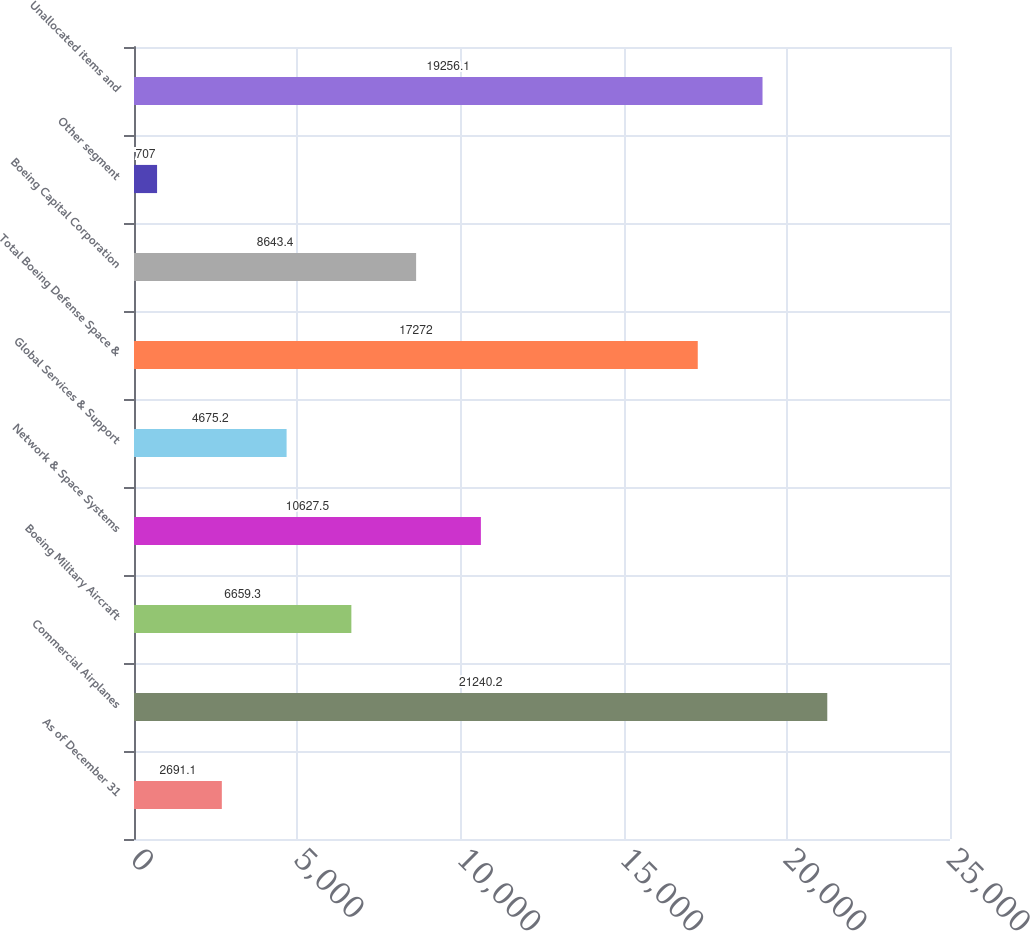<chart> <loc_0><loc_0><loc_500><loc_500><bar_chart><fcel>As of December 31<fcel>Commercial Airplanes<fcel>Boeing Military Aircraft<fcel>Network & Space Systems<fcel>Global Services & Support<fcel>Total Boeing Defense Space &<fcel>Boeing Capital Corporation<fcel>Other segment<fcel>Unallocated items and<nl><fcel>2691.1<fcel>21240.2<fcel>6659.3<fcel>10627.5<fcel>4675.2<fcel>17272<fcel>8643.4<fcel>707<fcel>19256.1<nl></chart> 